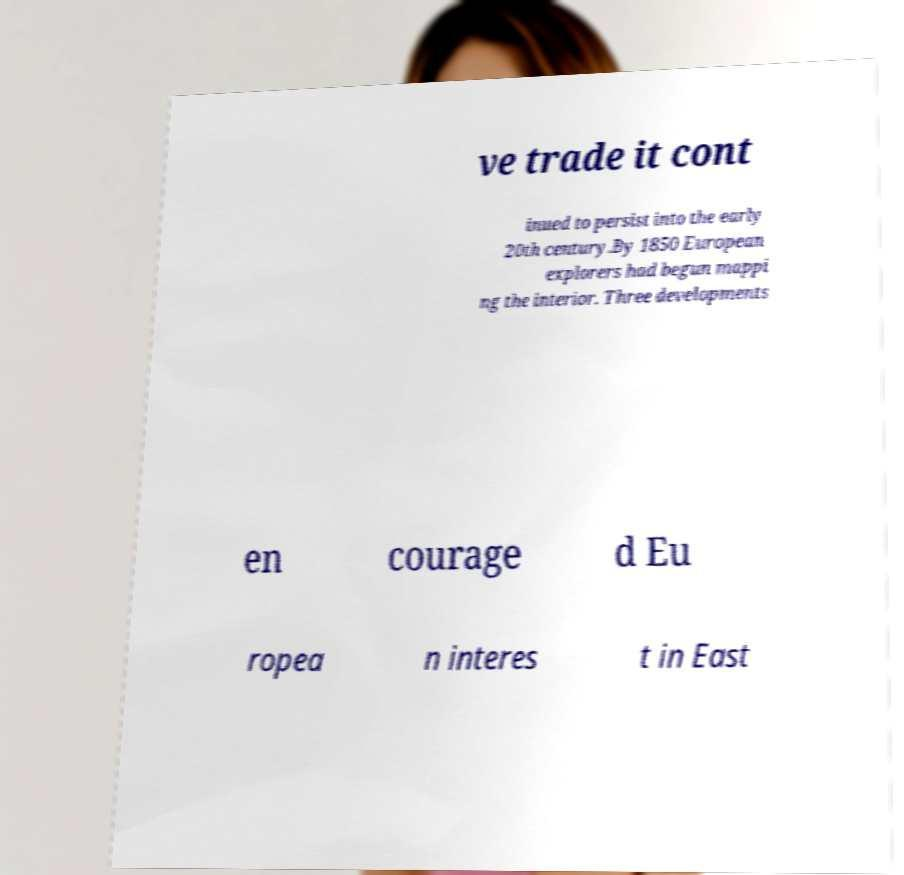Please identify and transcribe the text found in this image. ve trade it cont inued to persist into the early 20th century.By 1850 European explorers had begun mappi ng the interior. Three developments en courage d Eu ropea n interes t in East 